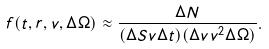<formula> <loc_0><loc_0><loc_500><loc_500>f ( t , { r } , { v } , \Delta \Omega ) \approx \frac { \Delta N } { ( \Delta S v \Delta t ) ( \Delta v v ^ { 2 } \Delta \Omega ) } .</formula> 